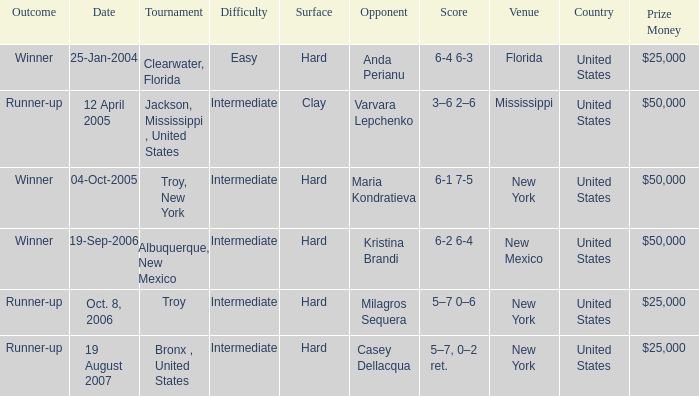What is the final score of the tournament played in Clearwater, Florida? 6-4 6-3. 